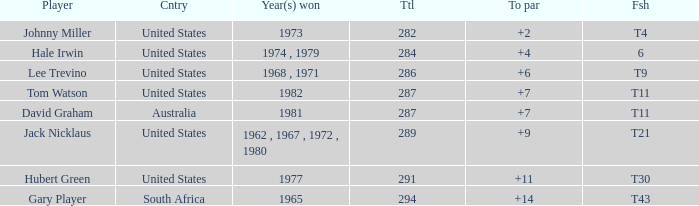WHAT IS THE TOTAL, OF A TO PAR FOR HUBERT GREEN, AND A TOTAL LARGER THAN 291? 0.0. 